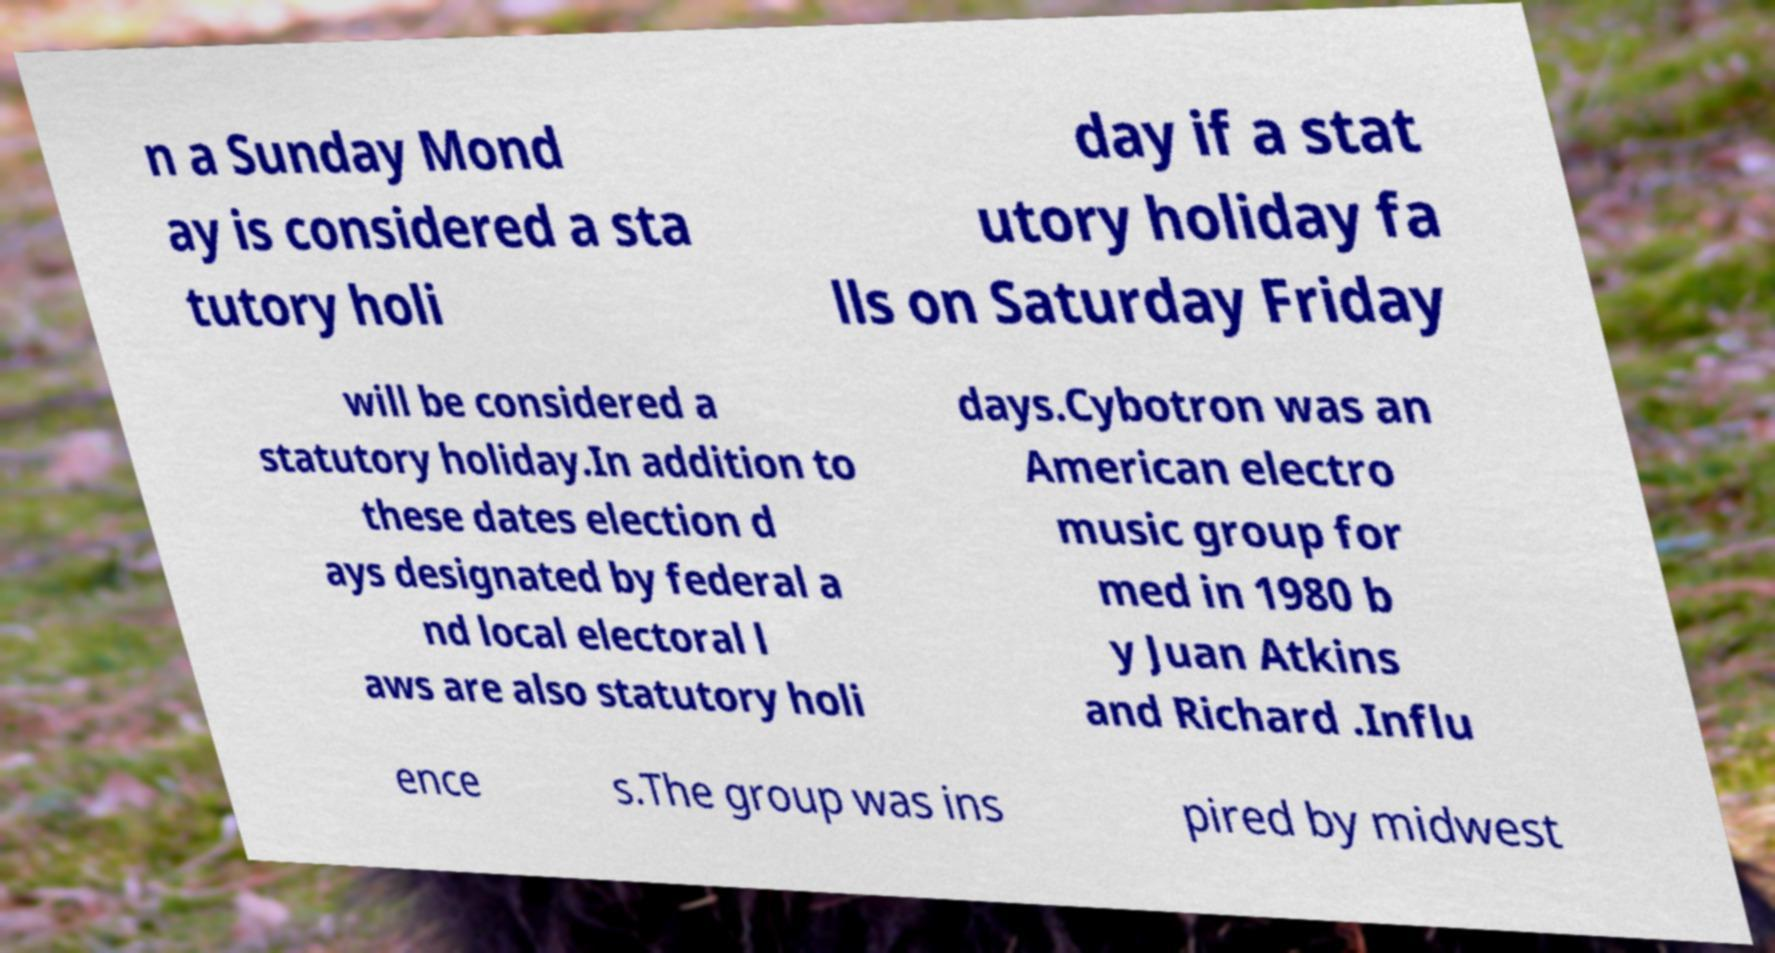I need the written content from this picture converted into text. Can you do that? n a Sunday Mond ay is considered a sta tutory holi day if a stat utory holiday fa lls on Saturday Friday will be considered a statutory holiday.In addition to these dates election d ays designated by federal a nd local electoral l aws are also statutory holi days.Cybotron was an American electro music group for med in 1980 b y Juan Atkins and Richard .Influ ence s.The group was ins pired by midwest 